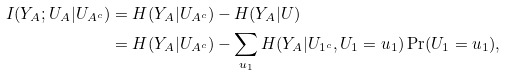Convert formula to latex. <formula><loc_0><loc_0><loc_500><loc_500>I ( Y _ { A } ; U _ { A } | U _ { A ^ { c } } ) & = H ( Y _ { A } | U _ { A ^ { c } } ) - H ( Y _ { A } | U ) \\ & = H ( Y _ { A } | U _ { A ^ { c } } ) - \sum _ { u _ { 1 } } H ( Y _ { A } | U _ { 1 ^ { c } } , U _ { 1 } = u _ { 1 } ) \Pr ( U _ { 1 } = u _ { 1 } ) ,</formula> 